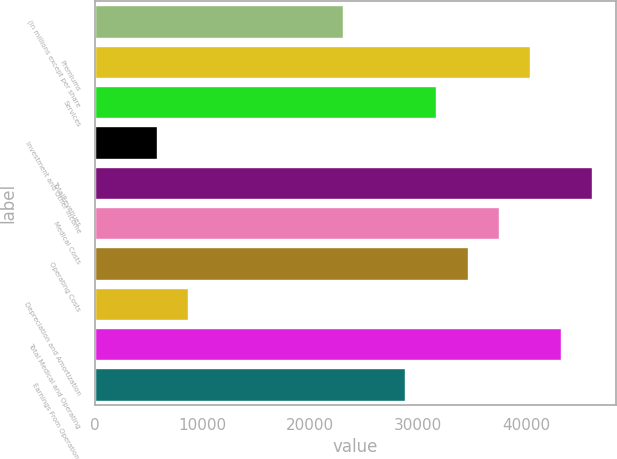Convert chart to OTSL. <chart><loc_0><loc_0><loc_500><loc_500><bar_chart><fcel>(in millions except per share<fcel>Premiums<fcel>Services<fcel>Investment and Other Income<fcel>TotalRevenues<fcel>Medical Costs<fcel>Operating Costs<fcel>Depreciation and Amortization<fcel>Total Medical and Operating<fcel>Earnings From Operations<nl><fcel>23069.6<fcel>40329.8<fcel>31699.7<fcel>5809.4<fcel>46083.2<fcel>37453.1<fcel>34576.4<fcel>8686.1<fcel>43206.5<fcel>28823<nl></chart> 